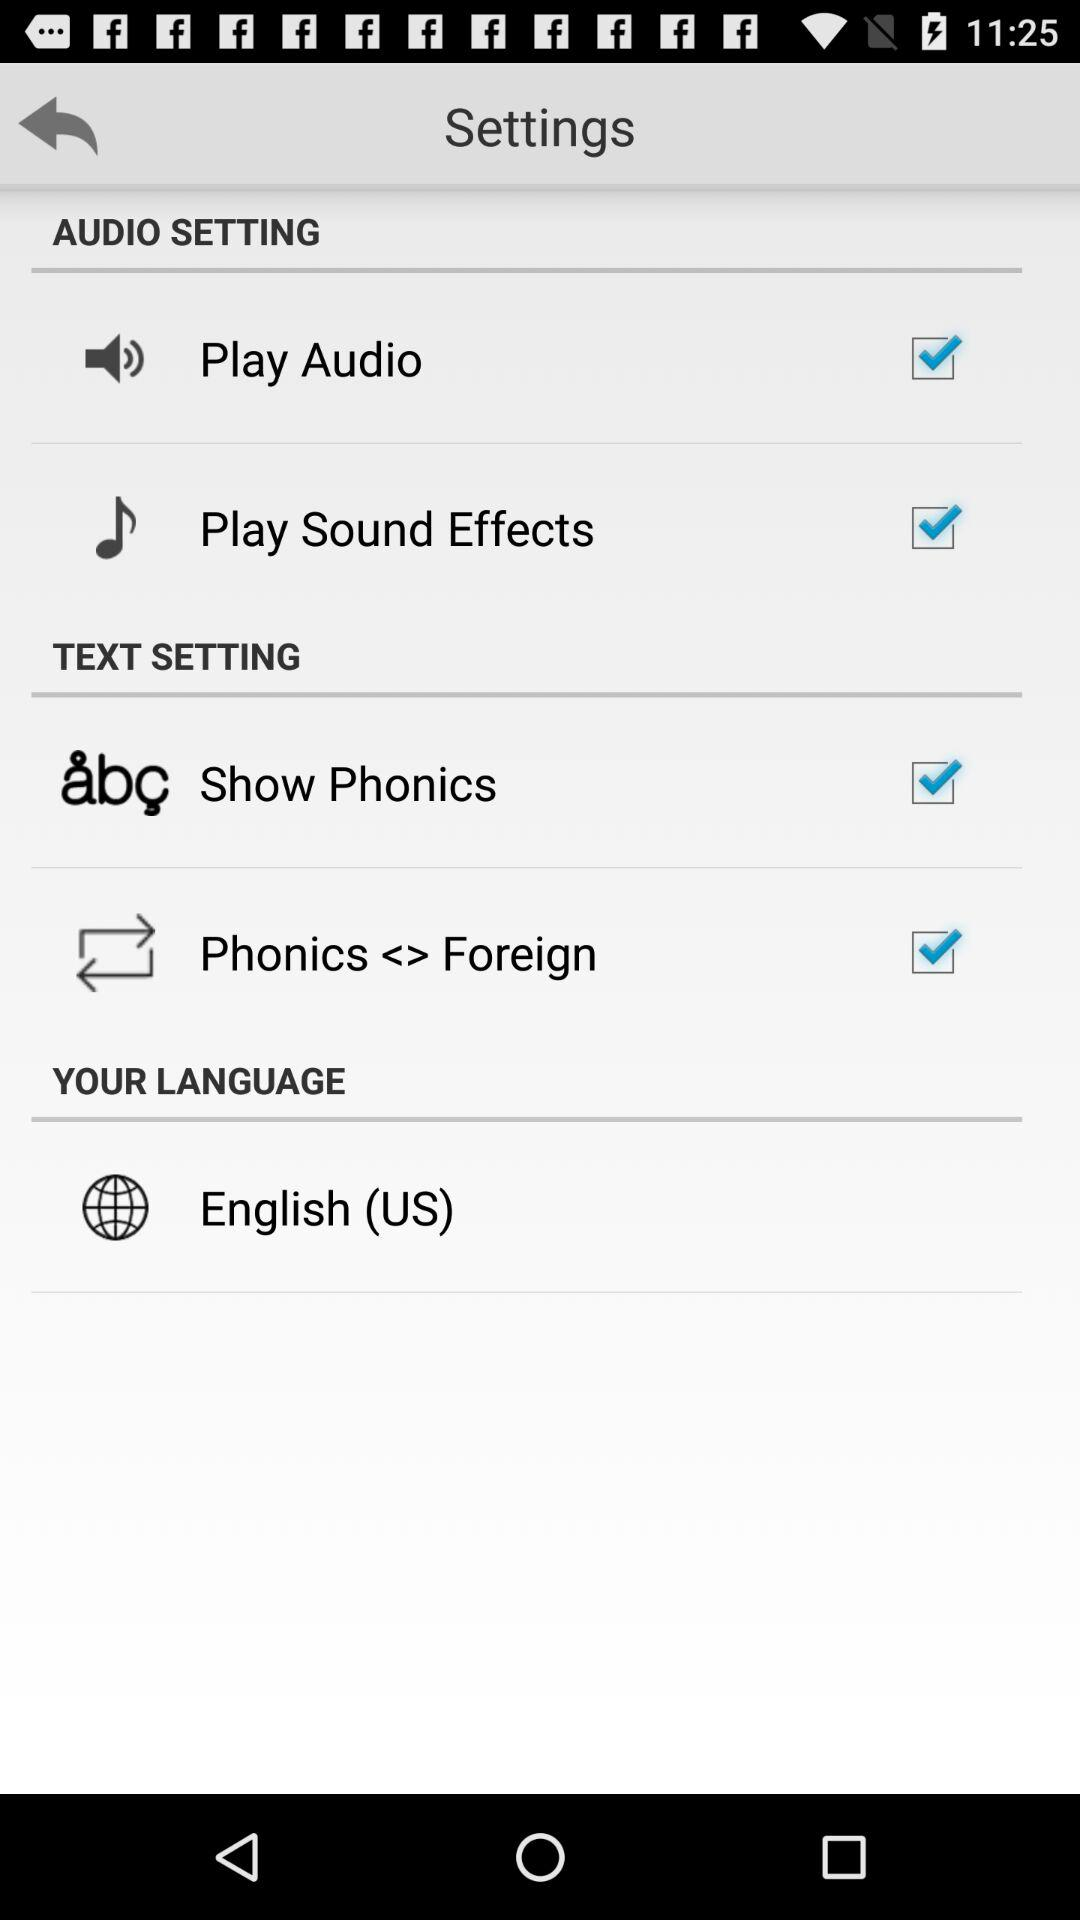What are the two options available in the text setting? The two options available in the text setting are : "Show Phonics" and "Phonics <> Foreign". 